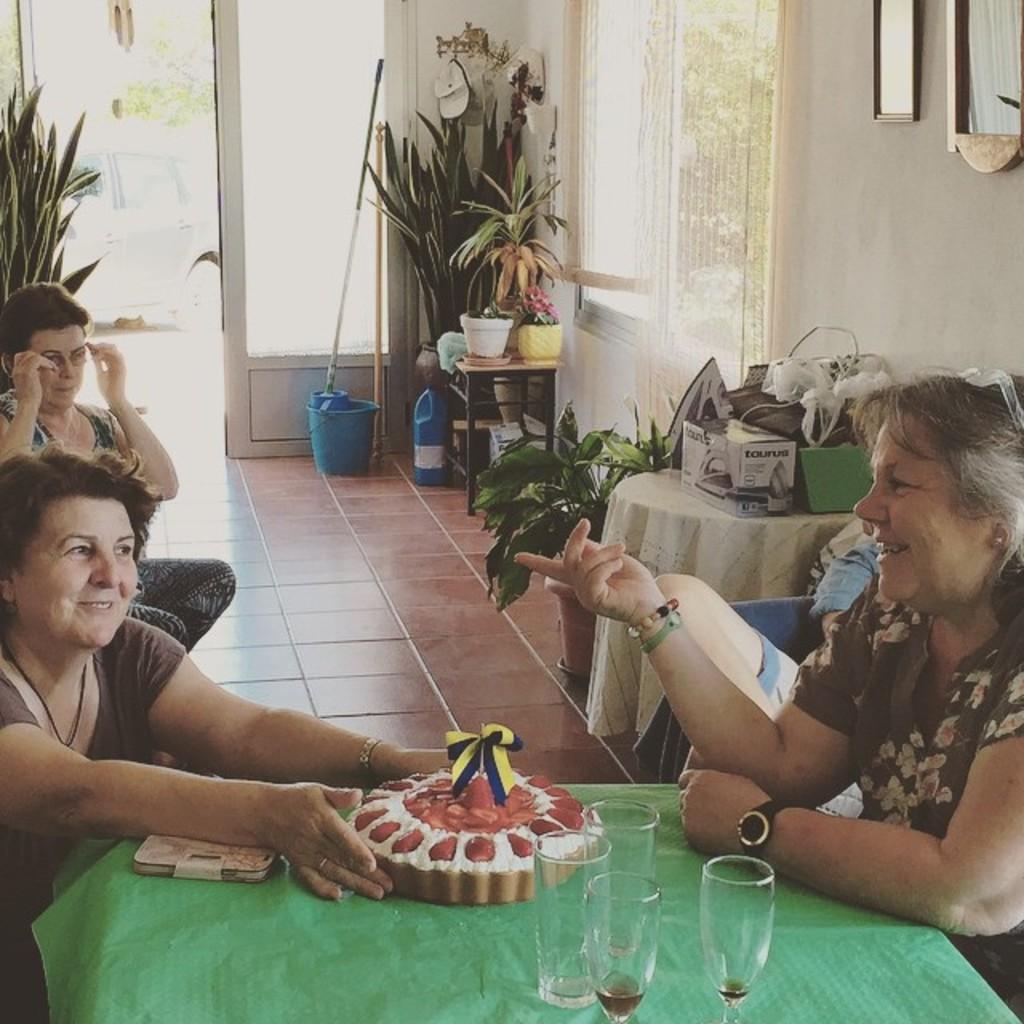Can you describe this image briefly? This two persons are sitting on chairs. In-between of them there is a table, on this table there are glasses, cake and mobile. Background there are plants, on this table there is a box, things and plants. On floor there is a bucket and bottle. A pictures on wall. From this door we can able to see a vehicle. 